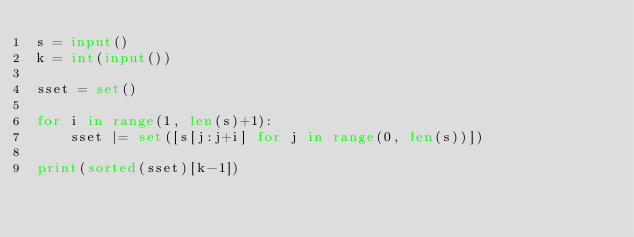Convert code to text. <code><loc_0><loc_0><loc_500><loc_500><_Python_>s = input()
k = int(input())

sset = set()

for i in range(1, len(s)+1):
    sset |= set([s[j:j+i] for j in range(0, len(s))])

print(sorted(sset)[k-1])</code> 